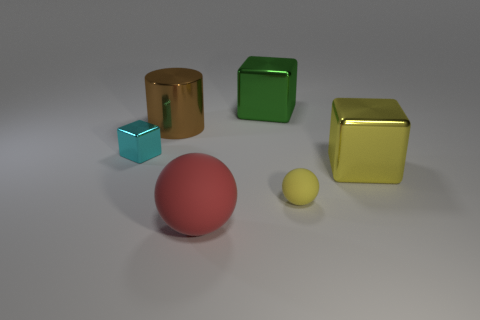There is a thing that is both in front of the yellow cube and behind the big red object; what size is it?
Your response must be concise. Small. The yellow sphere has what size?
Provide a short and direct response. Small. Are there more yellow cylinders than cyan blocks?
Your answer should be very brief. No. What is the red sphere made of?
Offer a terse response. Rubber. What color is the big metallic object on the left side of the red rubber sphere?
Make the answer very short. Brown. Are there more cylinders that are behind the cyan metal block than small matte spheres behind the large brown metal object?
Your answer should be very brief. Yes. What size is the metal block that is to the right of the small object on the right side of the big metallic block behind the cyan block?
Offer a terse response. Large. Is there a large metallic object of the same color as the tiny matte object?
Provide a short and direct response. Yes. How many small yellow shiny balls are there?
Your answer should be very brief. 0. The ball that is on the left side of the big block that is behind the metal cube left of the red matte thing is made of what material?
Ensure brevity in your answer.  Rubber. 